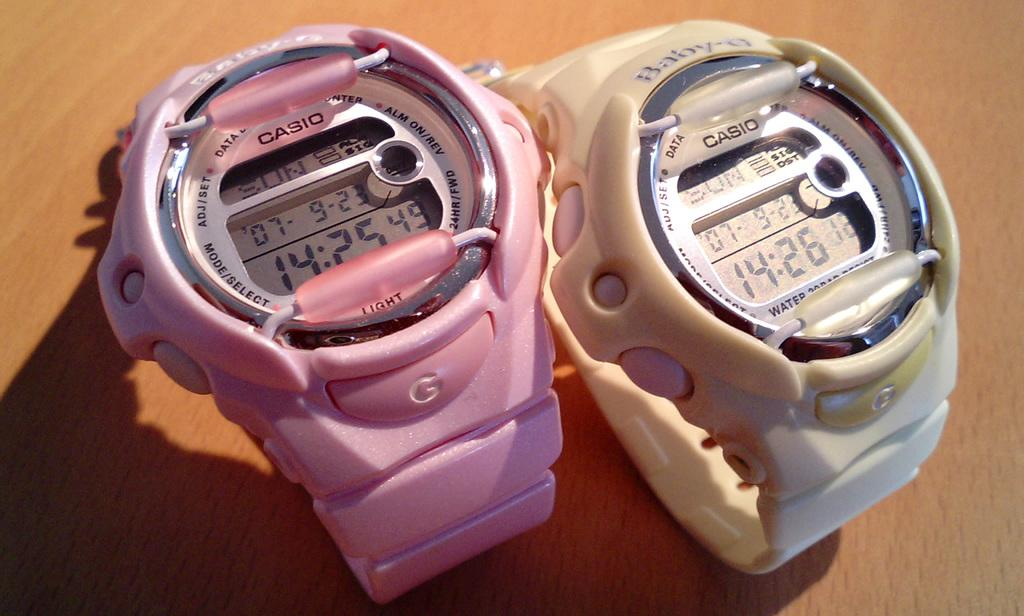Provide a one-sentence caption for the provided image. A pink Casio watch showing the time as 14:25 sits beside a white Casio watch showing the time as 14:26. 